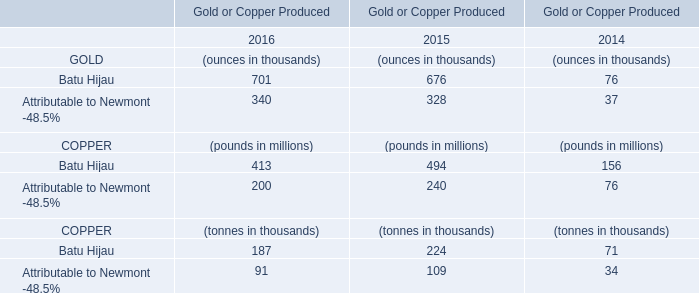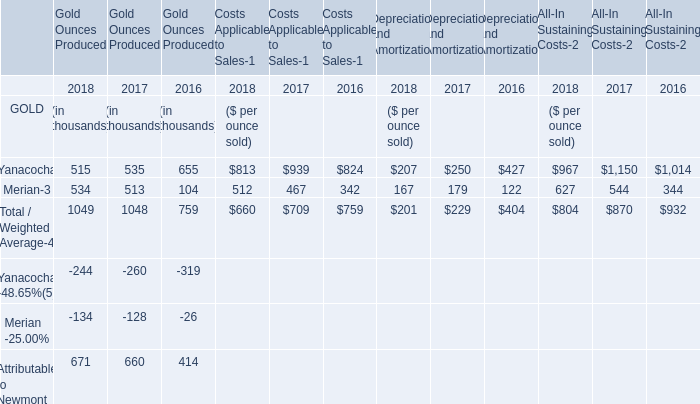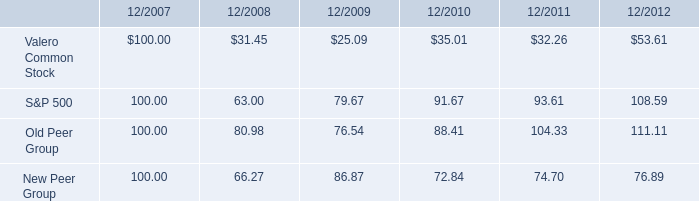In the year with least amount of Gold Ounces Produced by Yanacocha, what's the increasing rate of Gold Ounces Produced in terms of Total / Weighted Average? 
Computations: ((1049 - 1048) / 1048)
Answer: 0.00095. 